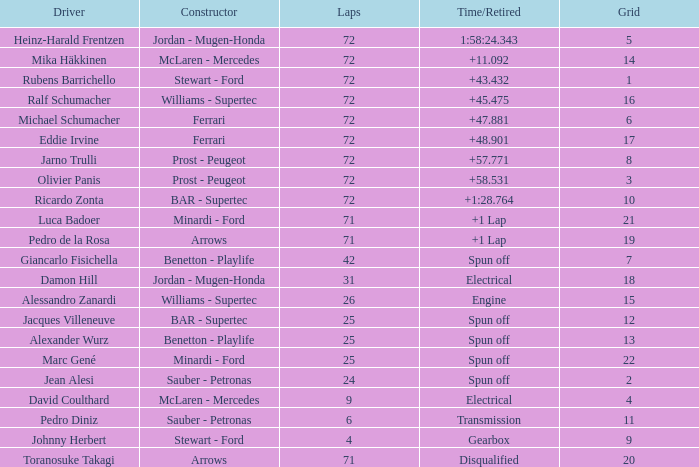How many laps did ricardo zonta race with a grid less than 14? 72.0. 